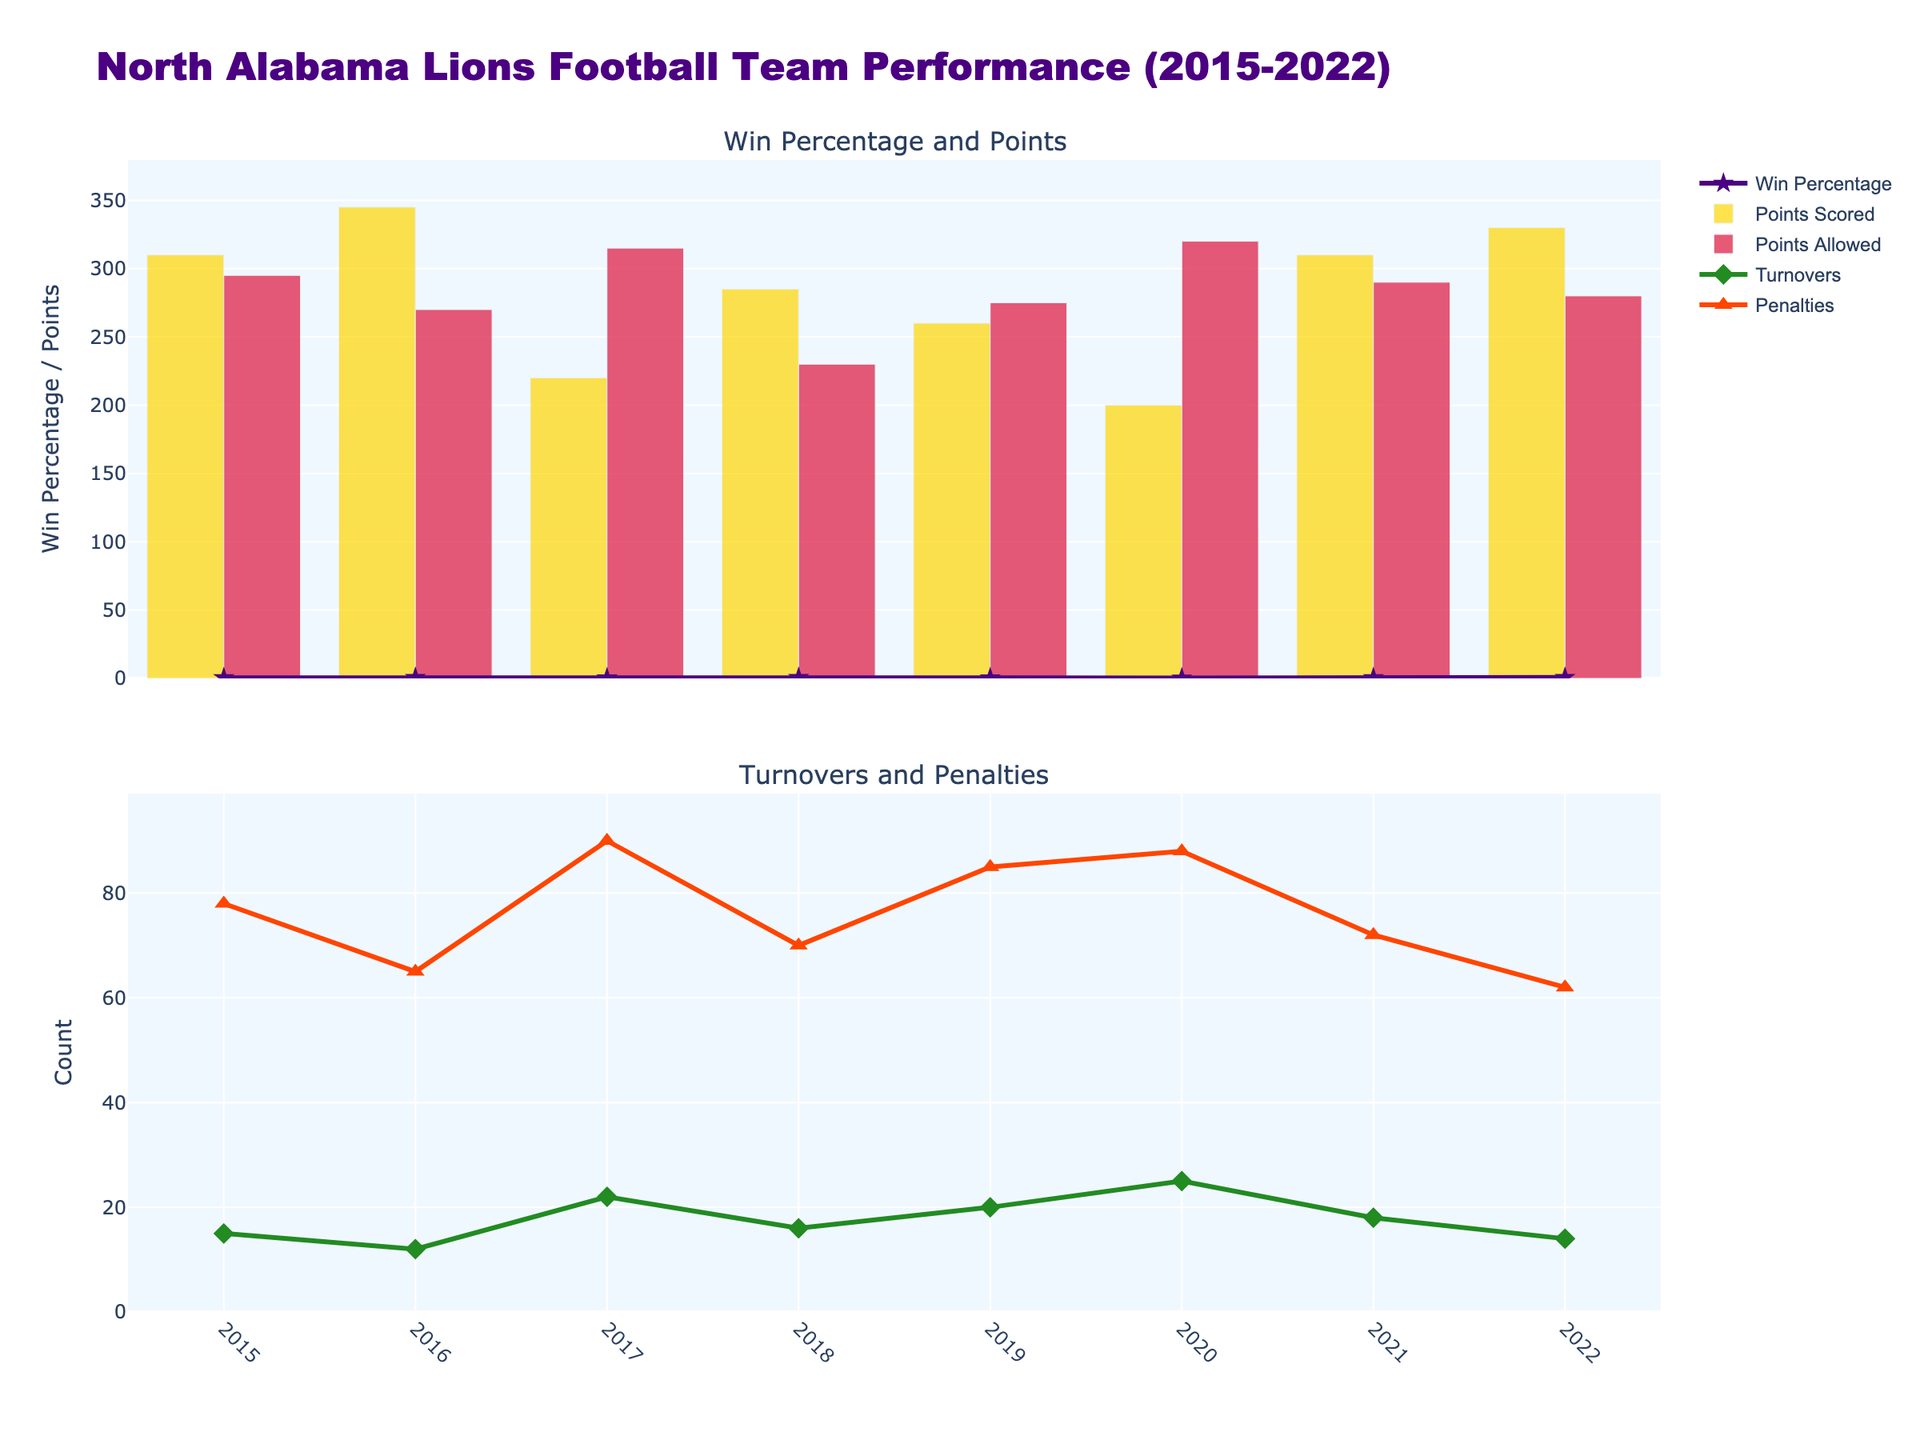What is the title of the plot? The title is displayed at the top of the plot, providing a summary of the plot's content. The title here is "North Alabama Lions Football Team Performance (2015-2022)."
Answer: North Alabama Lions Football Team Performance (2015-2022) Which season had the highest win percentage? Locate the line representing win percentage on the plot. The peak of the purple line indicates the highest win percentage, which occurs in the 2022 season.
Answer: 2022 During which season did the North Alabama Lions score the highest points? Identify the "Points Scored" bars on the plot. The tallest bar among these represents the season with the highest points scored. This occurs in the 2022 season.
Answer: 2022 Compare the penalties and turnovers in the 2020 season. Which was higher? Observe both the penalties and turnovers lines for the 2020 season. Compare the heights of the corresponding points; turnovers are higher with a count of 25 compared to 88 penalties.
Answer: Penalties How did turnovers change from 2019 to 2020? Follow the green line of turnovers from the 2019 point to the 2020 point. We notice that turnovers increased from 20 to 25.
Answer: Increased Which two seasons had the exact same number of games played? Observe the 'Games Played' for each season. 2018 and 2019 both had 11 games.
Answer: 2018 and 2019 What was the win percentage trend from 2019 to 2020? Track the win percentage between 2019 and 2020. It decreases from approximately 0.455 in 2019 to 0.300 in 2020.
Answer: Decreased Does a higher number of penalties correlate with a higher or lower number of wins? Generally, observe the overall trends of both penalties and wins. High penalties (such as in 2020) correlate with fewer wins, indicating a possible negative correlation.
Answer: Lower Which season had the lowest number of points scored? Look at the "Points Scored" bars and identify the shortest one. The 2017 season has the lowest points scored.
Answer: 2017 Were points allowed higher than points scored in 2021? Compare the height of the bars for points scored and points allowed in the 2021 season. Points scored (310) are higher than points allowed (290).
Answer: No 